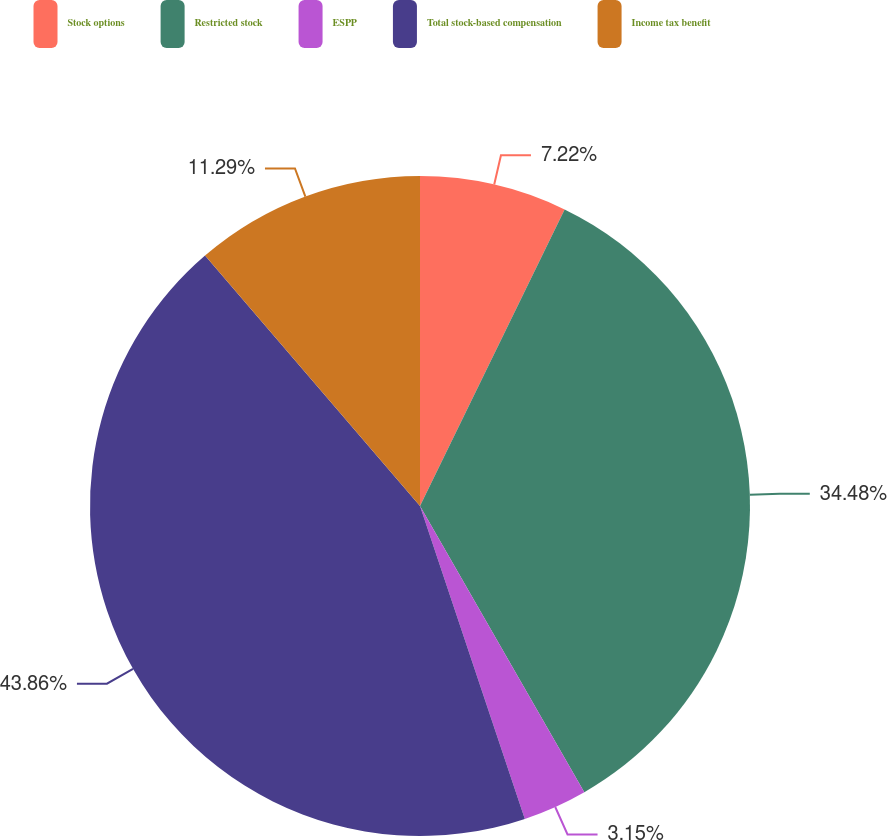Convert chart to OTSL. <chart><loc_0><loc_0><loc_500><loc_500><pie_chart><fcel>Stock options<fcel>Restricted stock<fcel>ESPP<fcel>Total stock-based compensation<fcel>Income tax benefit<nl><fcel>7.22%<fcel>34.48%<fcel>3.15%<fcel>43.85%<fcel>11.29%<nl></chart> 